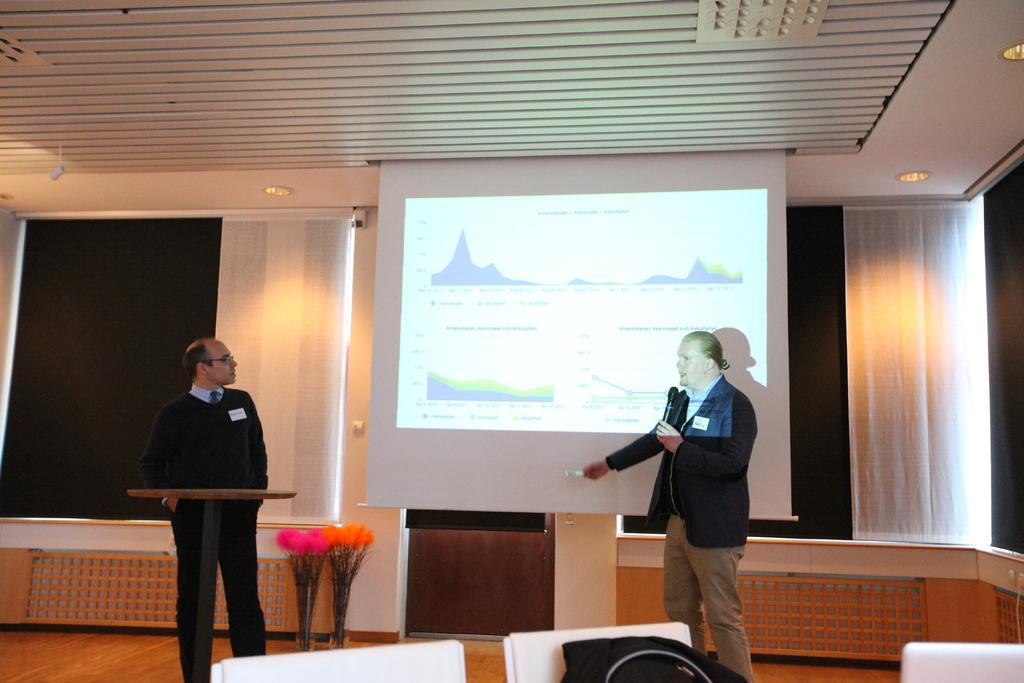Could you give a brief overview of what you see in this image? In this picture we can see there are two people standing and a person is holding a microphone. In front of the other person there is a table and chairs and on the chair there is a black object. Behind the people there are decorative plants, a projector screen and window shutters. At the top there are ceiling lights. 